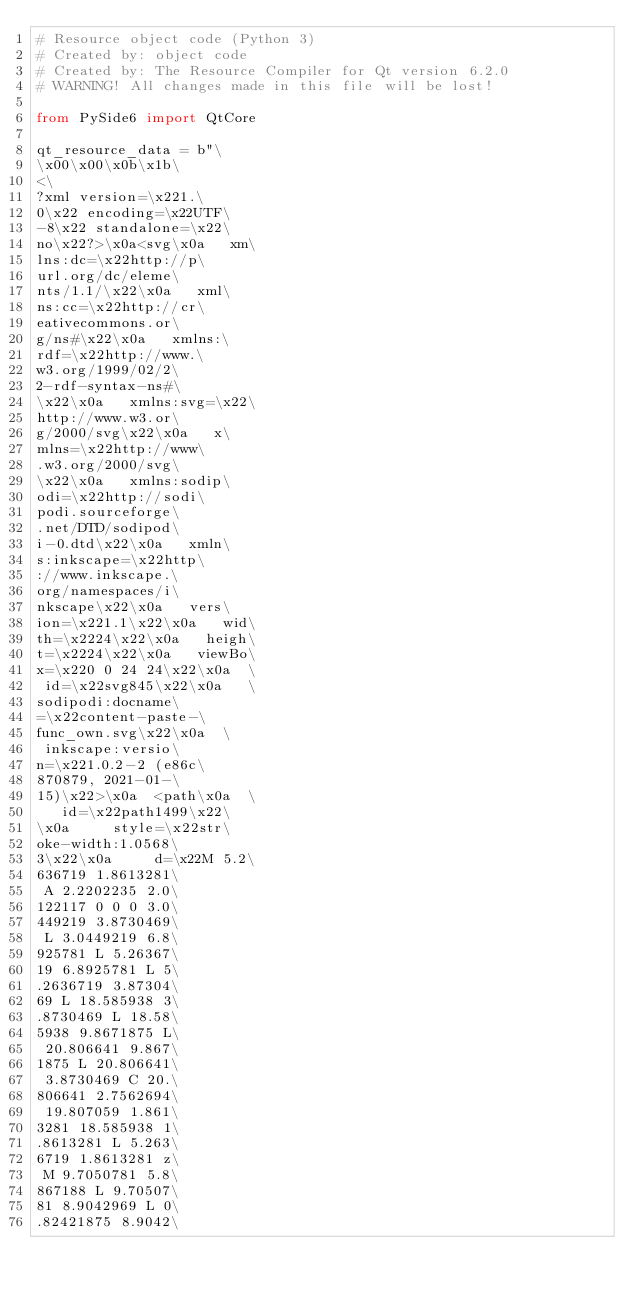<code> <loc_0><loc_0><loc_500><loc_500><_Python_># Resource object code (Python 3)
# Created by: object code
# Created by: The Resource Compiler for Qt version 6.2.0
# WARNING! All changes made in this file will be lost!

from PySide6 import QtCore

qt_resource_data = b"\
\x00\x00\x0b\x1b\
<\
?xml version=\x221.\
0\x22 encoding=\x22UTF\
-8\x22 standalone=\x22\
no\x22?>\x0a<svg\x0a   xm\
lns:dc=\x22http://p\
url.org/dc/eleme\
nts/1.1/\x22\x0a   xml\
ns:cc=\x22http://cr\
eativecommons.or\
g/ns#\x22\x0a   xmlns:\
rdf=\x22http://www.\
w3.org/1999/02/2\
2-rdf-syntax-ns#\
\x22\x0a   xmlns:svg=\x22\
http://www.w3.or\
g/2000/svg\x22\x0a   x\
mlns=\x22http://www\
.w3.org/2000/svg\
\x22\x0a   xmlns:sodip\
odi=\x22http://sodi\
podi.sourceforge\
.net/DTD/sodipod\
i-0.dtd\x22\x0a   xmln\
s:inkscape=\x22http\
://www.inkscape.\
org/namespaces/i\
nkscape\x22\x0a   vers\
ion=\x221.1\x22\x0a   wid\
th=\x2224\x22\x0a   heigh\
t=\x2224\x22\x0a   viewBo\
x=\x220 0 24 24\x22\x0a  \
 id=\x22svg845\x22\x0a   \
sodipodi:docname\
=\x22content-paste-\
func_own.svg\x22\x0a  \
 inkscape:versio\
n=\x221.0.2-2 (e86c\
870879, 2021-01-\
15)\x22>\x0a  <path\x0a  \
   id=\x22path1499\x22\
\x0a     style=\x22str\
oke-width:1.0568\
3\x22\x0a     d=\x22M 5.2\
636719 1.8613281\
 A 2.2202235 2.0\
122117 0 0 0 3.0\
449219 3.8730469\
 L 3.0449219 6.8\
925781 L 5.26367\
19 6.8925781 L 5\
.2636719 3.87304\
69 L 18.585938 3\
.8730469 L 18.58\
5938 9.8671875 L\
 20.806641 9.867\
1875 L 20.806641\
 3.8730469 C 20.\
806641 2.7562694\
 19.807059 1.861\
3281 18.585938 1\
.8613281 L 5.263\
6719 1.8613281 z\
 M 9.7050781 5.8\
867188 L 9.70507\
81 8.9042969 L 0\
.82421875 8.9042\</code> 